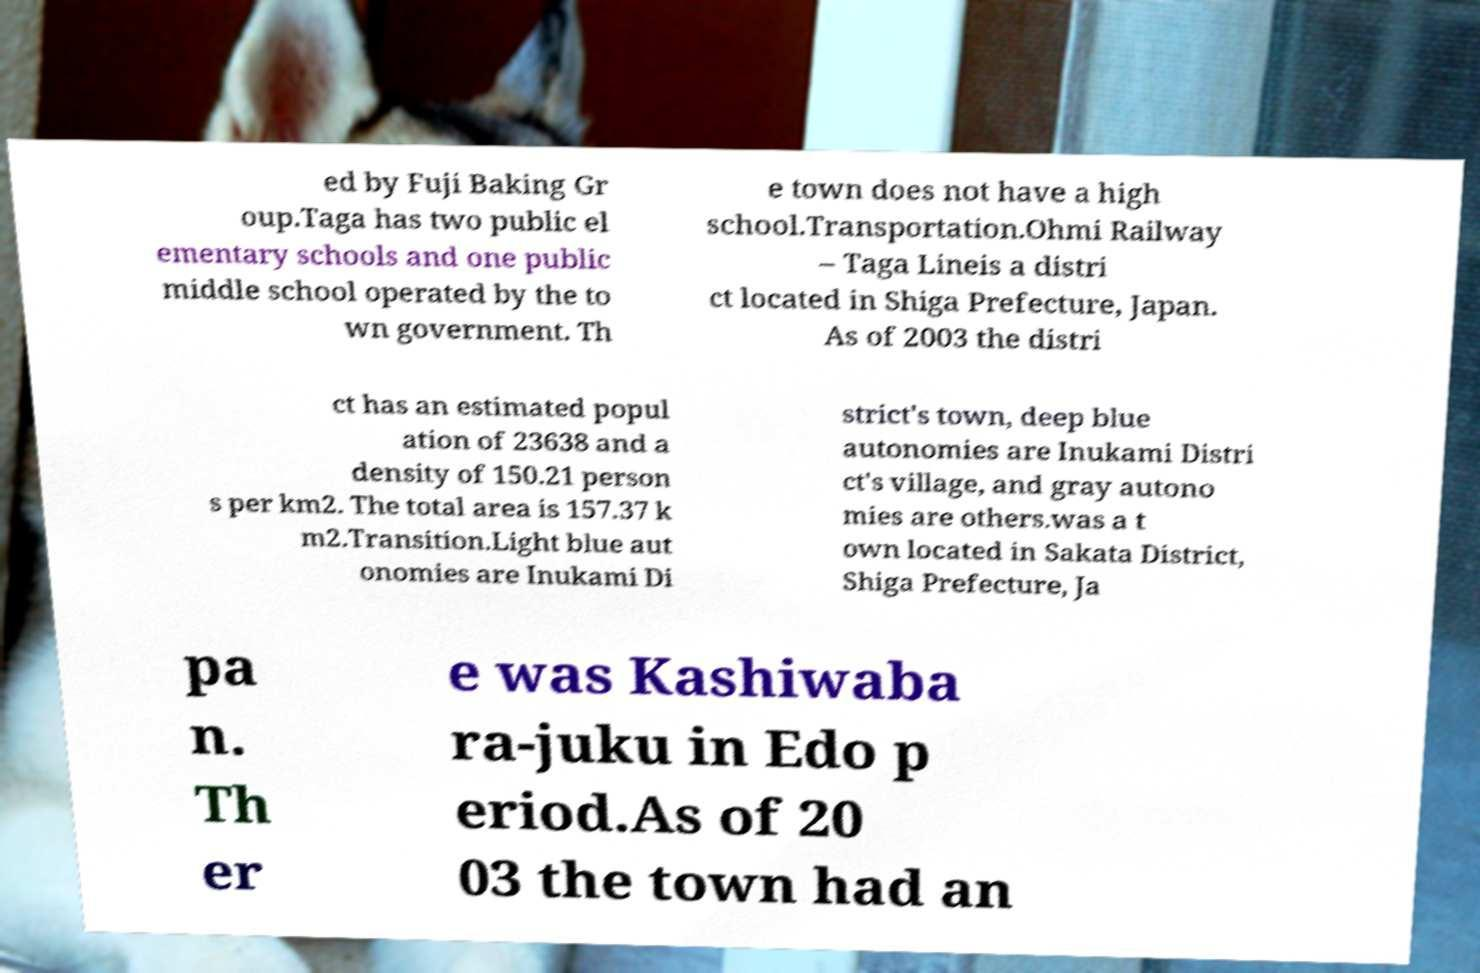There's text embedded in this image that I need extracted. Can you transcribe it verbatim? ed by Fuji Baking Gr oup.Taga has two public el ementary schools and one public middle school operated by the to wn government. Th e town does not have a high school.Transportation.Ohmi Railway – Taga Lineis a distri ct located in Shiga Prefecture, Japan. As of 2003 the distri ct has an estimated popul ation of 23638 and a density of 150.21 person s per km2. The total area is 157.37 k m2.Transition.Light blue aut onomies are Inukami Di strict's town, deep blue autonomies are Inukami Distri ct's village, and gray autono mies are others.was a t own located in Sakata District, Shiga Prefecture, Ja pa n. Th er e was Kashiwaba ra-juku in Edo p eriod.As of 20 03 the town had an 